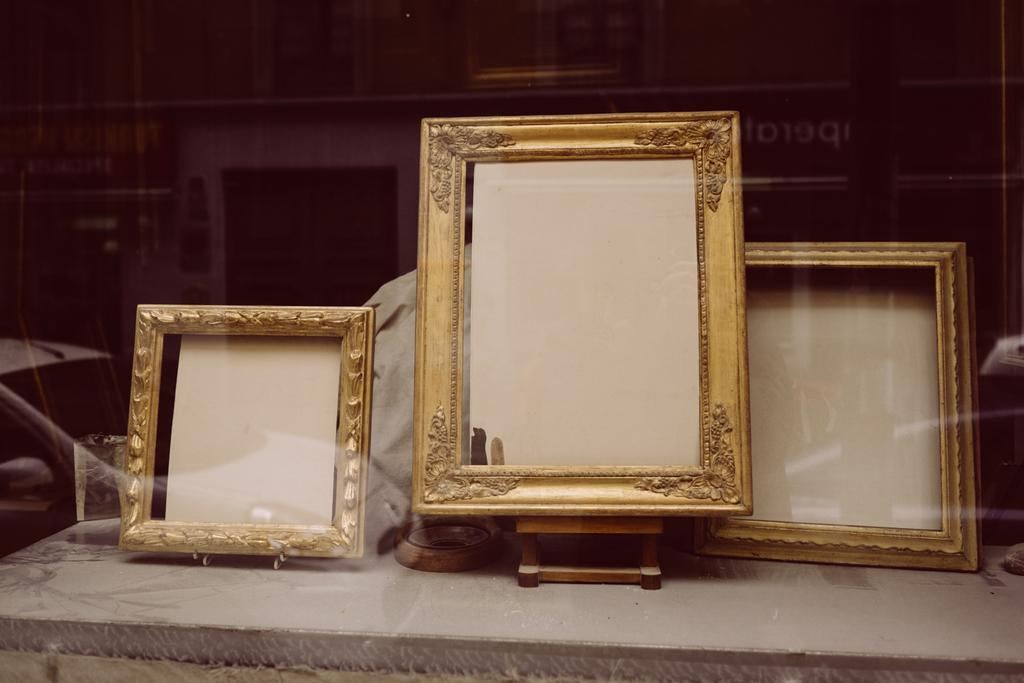What objects are present on the table in the foreground of the image? There are three frames on a table in the foreground of the image. What can be seen in the image due to the reflection of glass? There is a reflection of glass in the image, which allows us to see buildings in the background. What type of wax is being used to create friction on the moon in the image? There is no mention of the moon or wax in the image, so this question cannot be answered. 